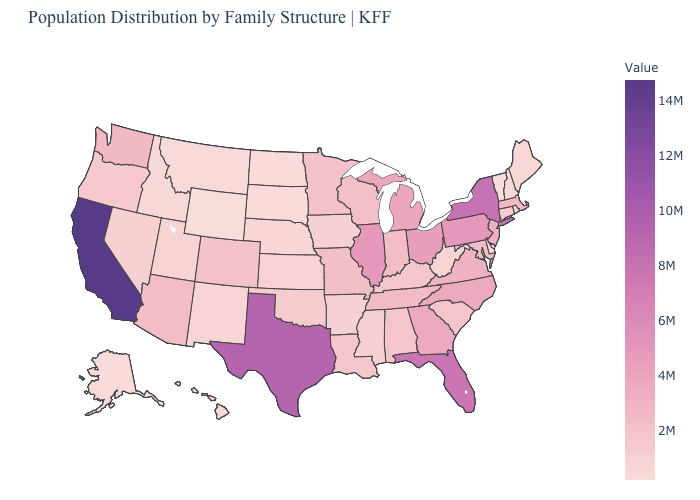Does Kentucky have a lower value than Wyoming?
Short answer required. No. Which states hav the highest value in the West?
Give a very brief answer. California. Is the legend a continuous bar?
Short answer required. Yes. Does Maine have the highest value in the Northeast?
Quick response, please. No. Among the states that border Massachusetts , which have the highest value?
Be succinct. New York. Does Louisiana have the lowest value in the USA?
Write a very short answer. No. Among the states that border Virginia , does North Carolina have the highest value?
Concise answer only. Yes. Which states have the lowest value in the USA?
Give a very brief answer. Wyoming. 